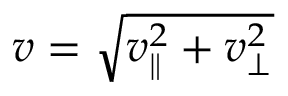<formula> <loc_0><loc_0><loc_500><loc_500>v = \sqrt { v _ { \| } ^ { 2 } + v _ { \perp } ^ { 2 } }</formula> 